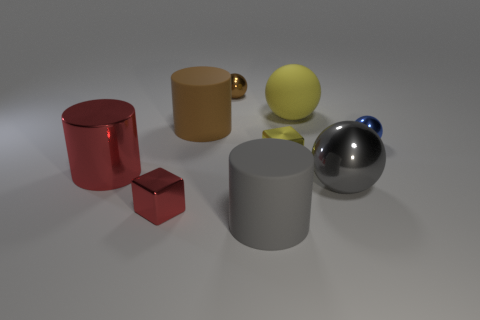There is a small thing that is the same color as the large matte ball; what material is it?
Provide a short and direct response. Metal. Are there fewer large brown cylinders than matte cylinders?
Your response must be concise. Yes. Is there any other thing that has the same size as the yellow matte sphere?
Make the answer very short. Yes. Is the rubber ball the same color as the big shiny ball?
Provide a succinct answer. No. Are there more small red cylinders than big gray matte cylinders?
Provide a succinct answer. No. How many other objects are the same color as the big metal cylinder?
Offer a terse response. 1. There is a tiny thing that is right of the gray shiny thing; how many small brown metallic things are to the right of it?
Provide a short and direct response. 0. Are there any yellow matte spheres behind the small brown ball?
Keep it short and to the point. No. What is the shape of the matte thing that is in front of the metallic thing on the right side of the big metallic sphere?
Your answer should be compact. Cylinder. Are there fewer large gray metal balls that are in front of the small yellow shiny block than small blue shiny spheres that are on the left side of the red metal cylinder?
Provide a succinct answer. No. 